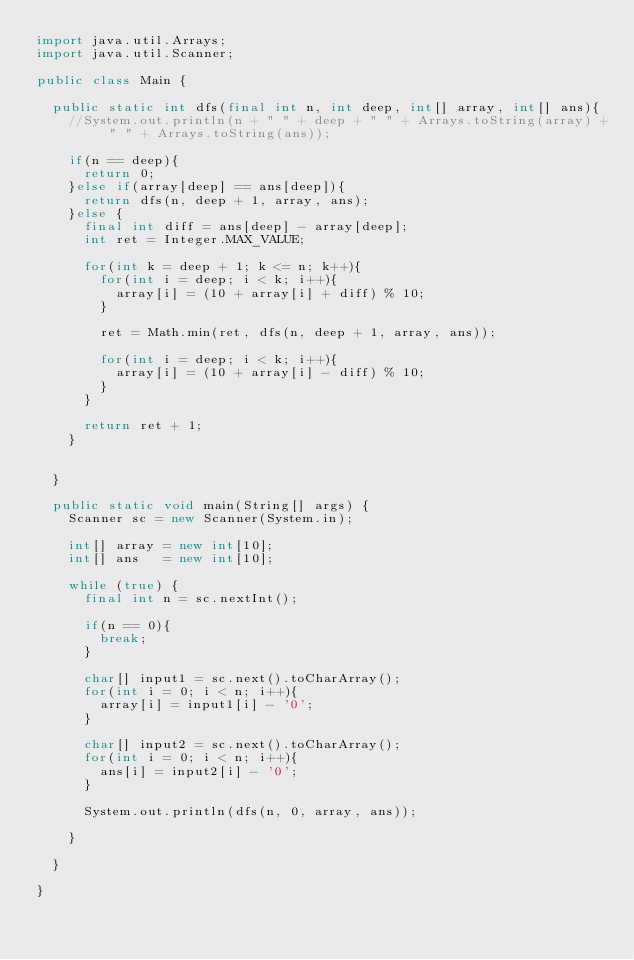<code> <loc_0><loc_0><loc_500><loc_500><_Java_>import java.util.Arrays;
import java.util.Scanner;

public class Main {
	
	public static int dfs(final int n, int deep, int[] array, int[] ans){
		//System.out.println(n + " " + deep + " " + Arrays.toString(array) + " " + Arrays.toString(ans));
		
		if(n == deep){
			return 0;
		}else if(array[deep] == ans[deep]){
			return dfs(n, deep + 1, array, ans);
		}else {
			final int diff = ans[deep] - array[deep];
			int ret = Integer.MAX_VALUE;
			
			for(int k = deep + 1; k <= n; k++){
				for(int i = deep; i < k; i++){
					array[i] = (10 + array[i] + diff) % 10;
				}
			
				ret = Math.min(ret, dfs(n, deep + 1, array, ans));
			
				for(int i = deep; i < k; i++){
					array[i] = (10 + array[i] - diff) % 10;
				}
			}
			
			return ret + 1;
		}
		
		
	}
	
	public static void main(String[] args) {
		Scanner sc = new Scanner(System.in);

		int[] array = new int[10];
		int[] ans   = new int[10];
		
		while (true) {
			final int n = sc.nextInt();
			
			if(n == 0){
				break;
			}
			
			char[] input1 = sc.next().toCharArray();
			for(int i = 0; i < n; i++){
				array[i] = input1[i] - '0';
			}
			
			char[] input2 = sc.next().toCharArray();
			for(int i = 0; i < n; i++){
				ans[i] = input2[i] - '0';
			}
			
			System.out.println(dfs(n, 0, array, ans));
			
		}

	}

}</code> 